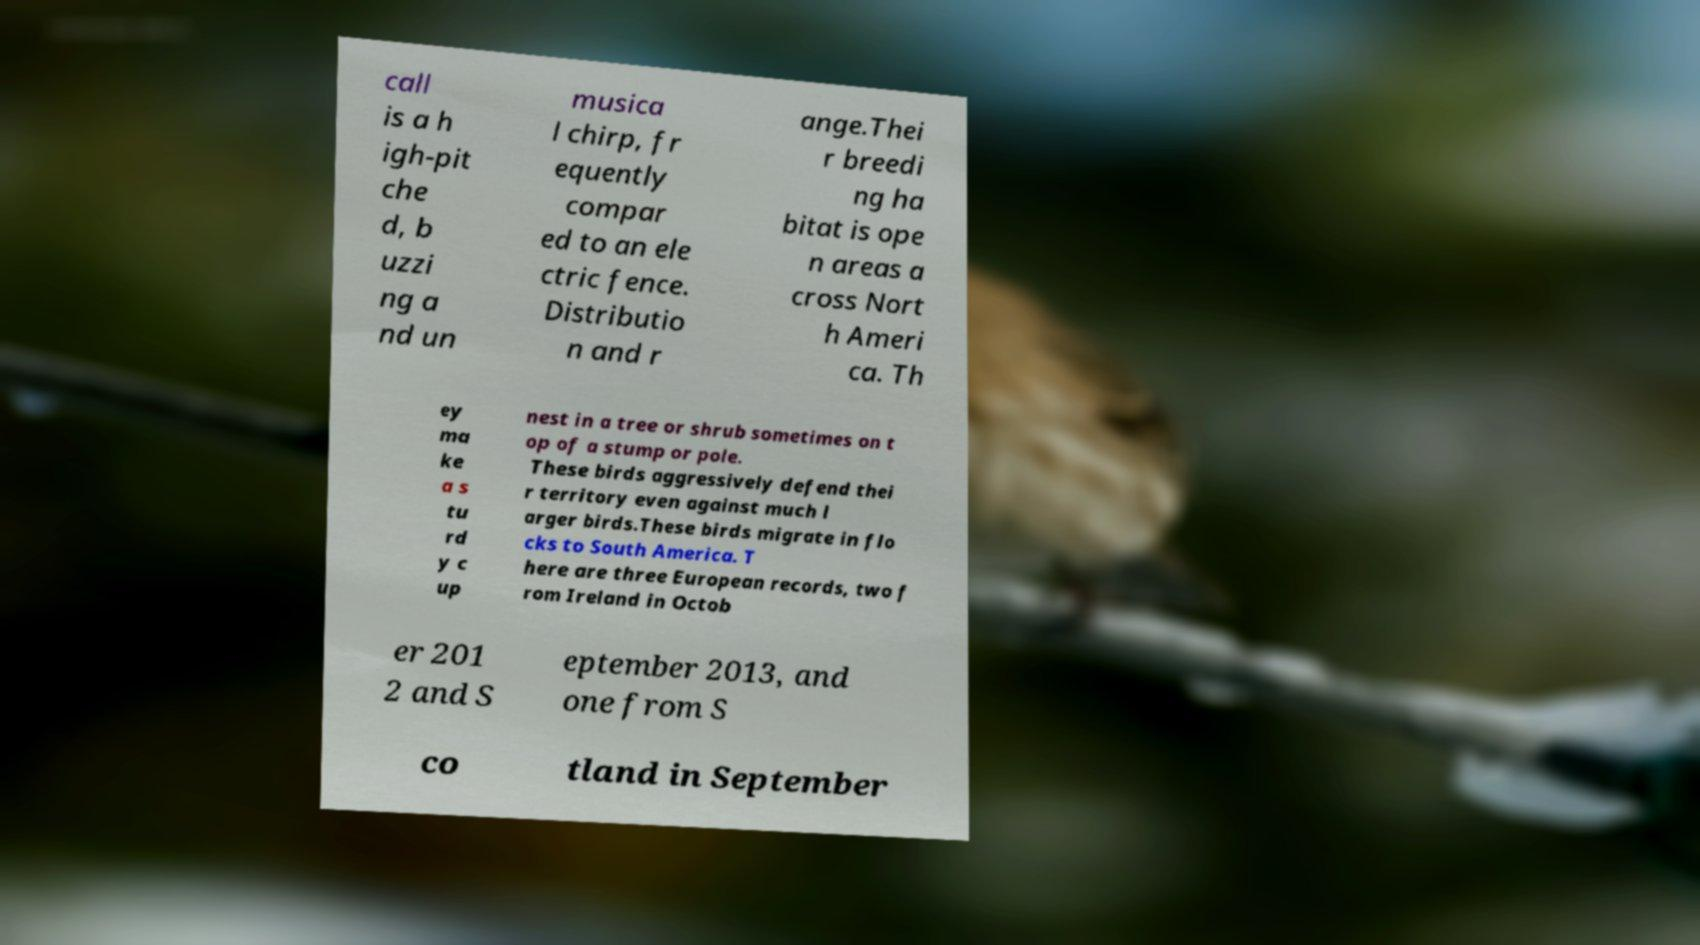Could you extract and type out the text from this image? call is a h igh-pit che d, b uzzi ng a nd un musica l chirp, fr equently compar ed to an ele ctric fence. Distributio n and r ange.Thei r breedi ng ha bitat is ope n areas a cross Nort h Ameri ca. Th ey ma ke a s tu rd y c up nest in a tree or shrub sometimes on t op of a stump or pole. These birds aggressively defend thei r territory even against much l arger birds.These birds migrate in flo cks to South America. T here are three European records, two f rom Ireland in Octob er 201 2 and S eptember 2013, and one from S co tland in September 